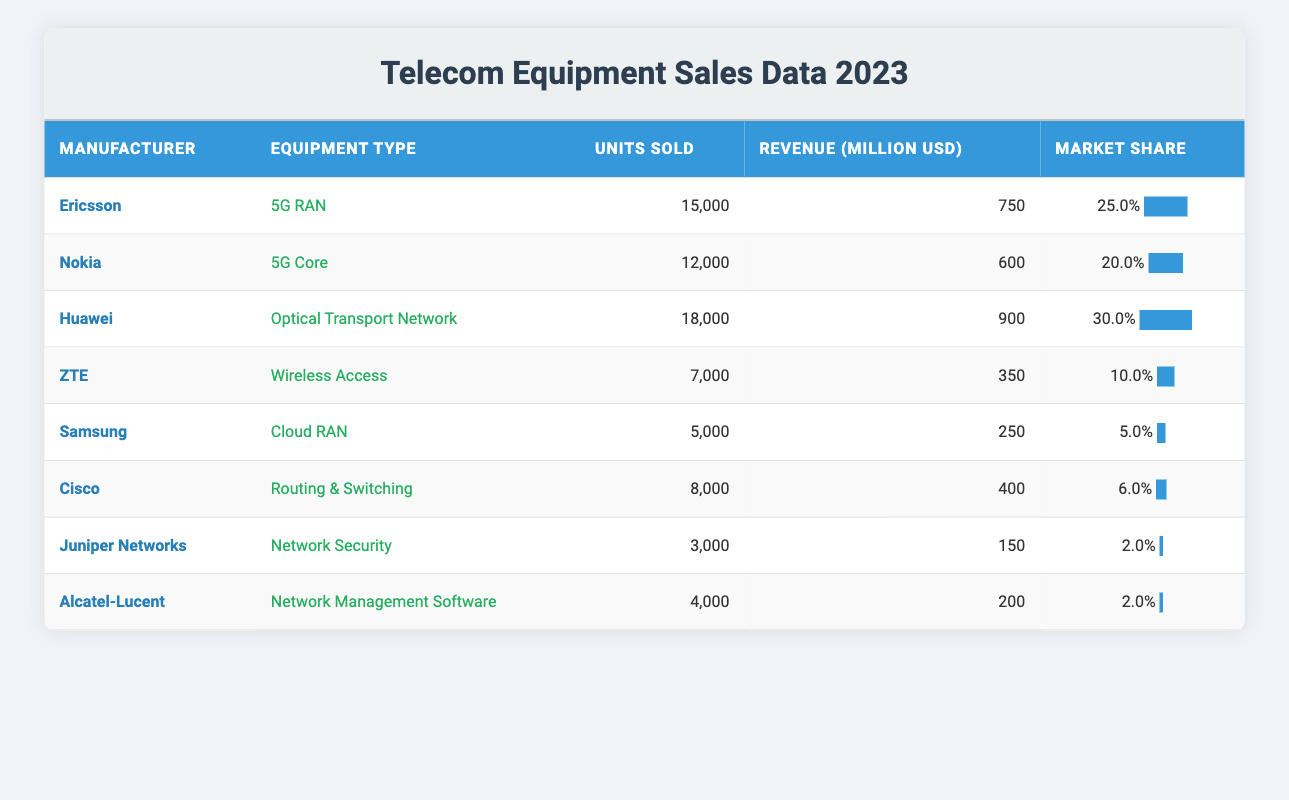What is the total revenue generated by all manufacturers in 2023? To find the total revenue, we can add up the revenue from each manufacturer. The revenues are: 750 + 600 + 900 + 350 + 250 + 400 + 150 + 200 = 3100 million USD
Answer: 3100 million USD Which manufacturer sold the highest number of units? Looking at the units sold, Huawei sold the highest with 18000 units.
Answer: Huawei Is the market share percentage for Ericsson greater than that of Samsung? Ericsson has a market share of 25.0% while Samsung has a market share of 5.0%, so yes, Ericsson's market share is indeed greater.
Answer: Yes What is the average number of units sold across all manufacturers? To find the average, we sum the units sold (15000 + 12000 + 18000 + 7000 + 5000 + 8000 + 3000 + 4000 =  100000) and divide by the number of manufacturers (8): 100000 / 8 = 12500 units.
Answer: 12500 units How much revenue did Cisco generate compared to Ericsson? Cisco generated 400 million USD, while Ericsson generated 750 million USD. Thus, Ericsson's revenue is higher than Cisco's.
Answer: Ericsson generated more revenue Which manufacturer has the lowest market share percentage? Juniper Networks and Alcatel-Lucent both have a market share of 2.0%, which is the lowest among all manufacturers listed.
Answer: Juniper Networks and Alcatel-Lucent If the units sold by ZTE were doubled, how many units would they have sold? ZTE sold 7000 units, so if this amount is doubled, it would be 7000 * 2 = 14000 units.
Answer: 14000 units What percentage of units sold does Samsung represent in comparison with the total units sold? Samsung sold 5000 units; the total units sold is 100000. To find the percentage, we calculate (5000 / 100000) * 100 = 5%.
Answer: 5% Which equipment type has the highest revenue and what is that revenue? The equipment type with the highest revenue is the Optical Transport Network sold by Huawei, generating 900 million USD.
Answer: Optical Transport Network, 900 million USD 